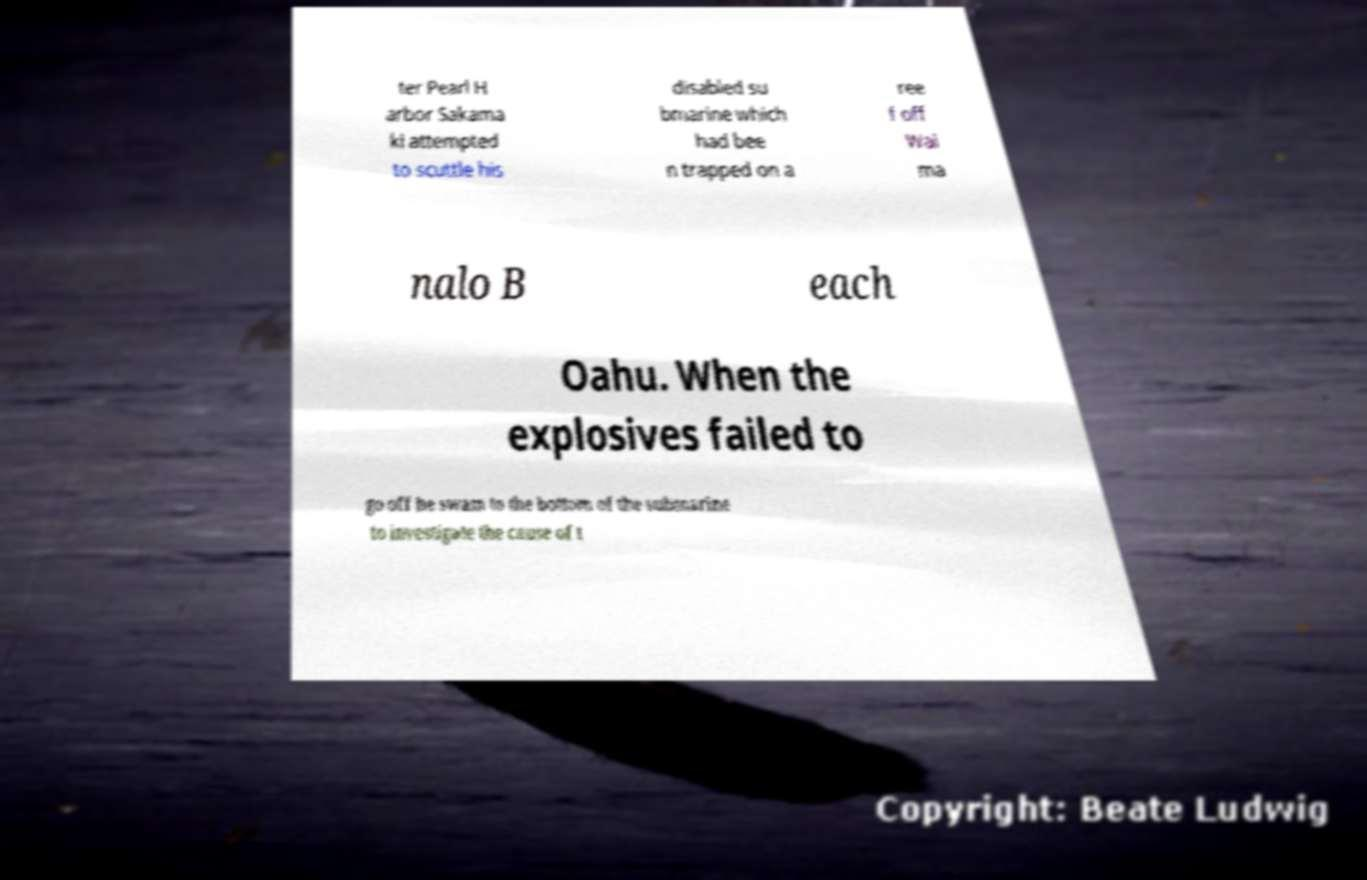Please read and relay the text visible in this image. What does it say? ter Pearl H arbor Sakama ki attempted to scuttle his disabled su bmarine which had bee n trapped on a ree f off Wai ma nalo B each Oahu. When the explosives failed to go off he swam to the bottom of the submarine to investigate the cause of t 